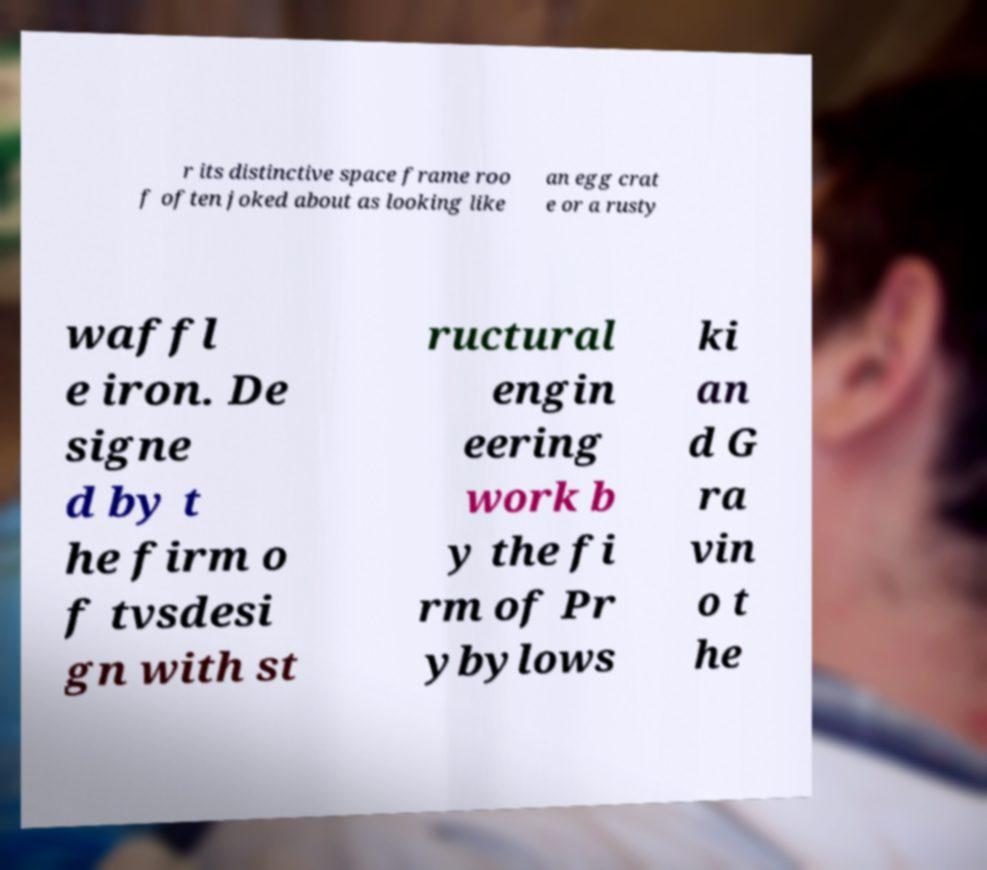Can you accurately transcribe the text from the provided image for me? r its distinctive space frame roo f often joked about as looking like an egg crat e or a rusty waffl e iron. De signe d by t he firm o f tvsdesi gn with st ructural engin eering work b y the fi rm of Pr ybylows ki an d G ra vin o t he 